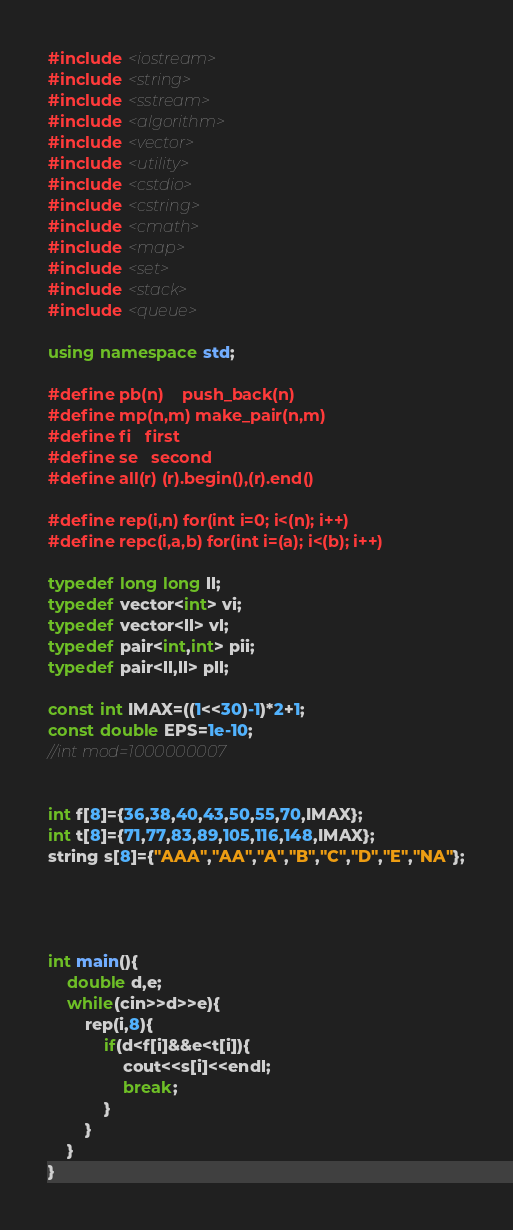<code> <loc_0><loc_0><loc_500><loc_500><_C++_>#include <iostream>
#include <string>
#include <sstream>
#include <algorithm>
#include <vector>
#include <utility>
#include <cstdio>
#include <cstring>
#include <cmath>
#include <map>
#include <set>
#include <stack>
#include <queue>
 
using namespace std;
 
#define pb(n)	push_back(n)
#define mp(n,m) make_pair(n,m)
#define fi 	first
#define se 	second
#define all(r) (r).begin(),(r).end()

#define rep(i,n) for(int i=0; i<(n); i++)
#define repc(i,a,b) for(int i=(a); i<(b); i++)

typedef long long ll;
typedef vector<int> vi;
typedef vector<ll> vl;
typedef pair<int,int> pii;
typedef pair<ll,ll> pll;
 
const int IMAX=((1<<30)-1)*2+1;
const double EPS=1e-10;
//int mod=1000000007


int f[8]={36,38,40,43,50,55,70,IMAX};
int t[8]={71,77,83,89,105,116,148,IMAX};
string s[8]={"AAA","AA","A","B","C","D","E","NA"};




int main(){
	double d,e;
	while(cin>>d>>e){
		rep(i,8){
			if(d<f[i]&&e<t[i]){
				cout<<s[i]<<endl;
				break;
			}
		}
	}
}</code> 